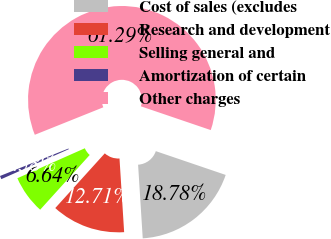Convert chart to OTSL. <chart><loc_0><loc_0><loc_500><loc_500><pie_chart><fcel>Cost of sales (excludes<fcel>Research and development<fcel>Selling general and<fcel>Amortization of certain<fcel>Other charges<nl><fcel>18.78%<fcel>12.71%<fcel>6.64%<fcel>0.58%<fcel>61.29%<nl></chart> 